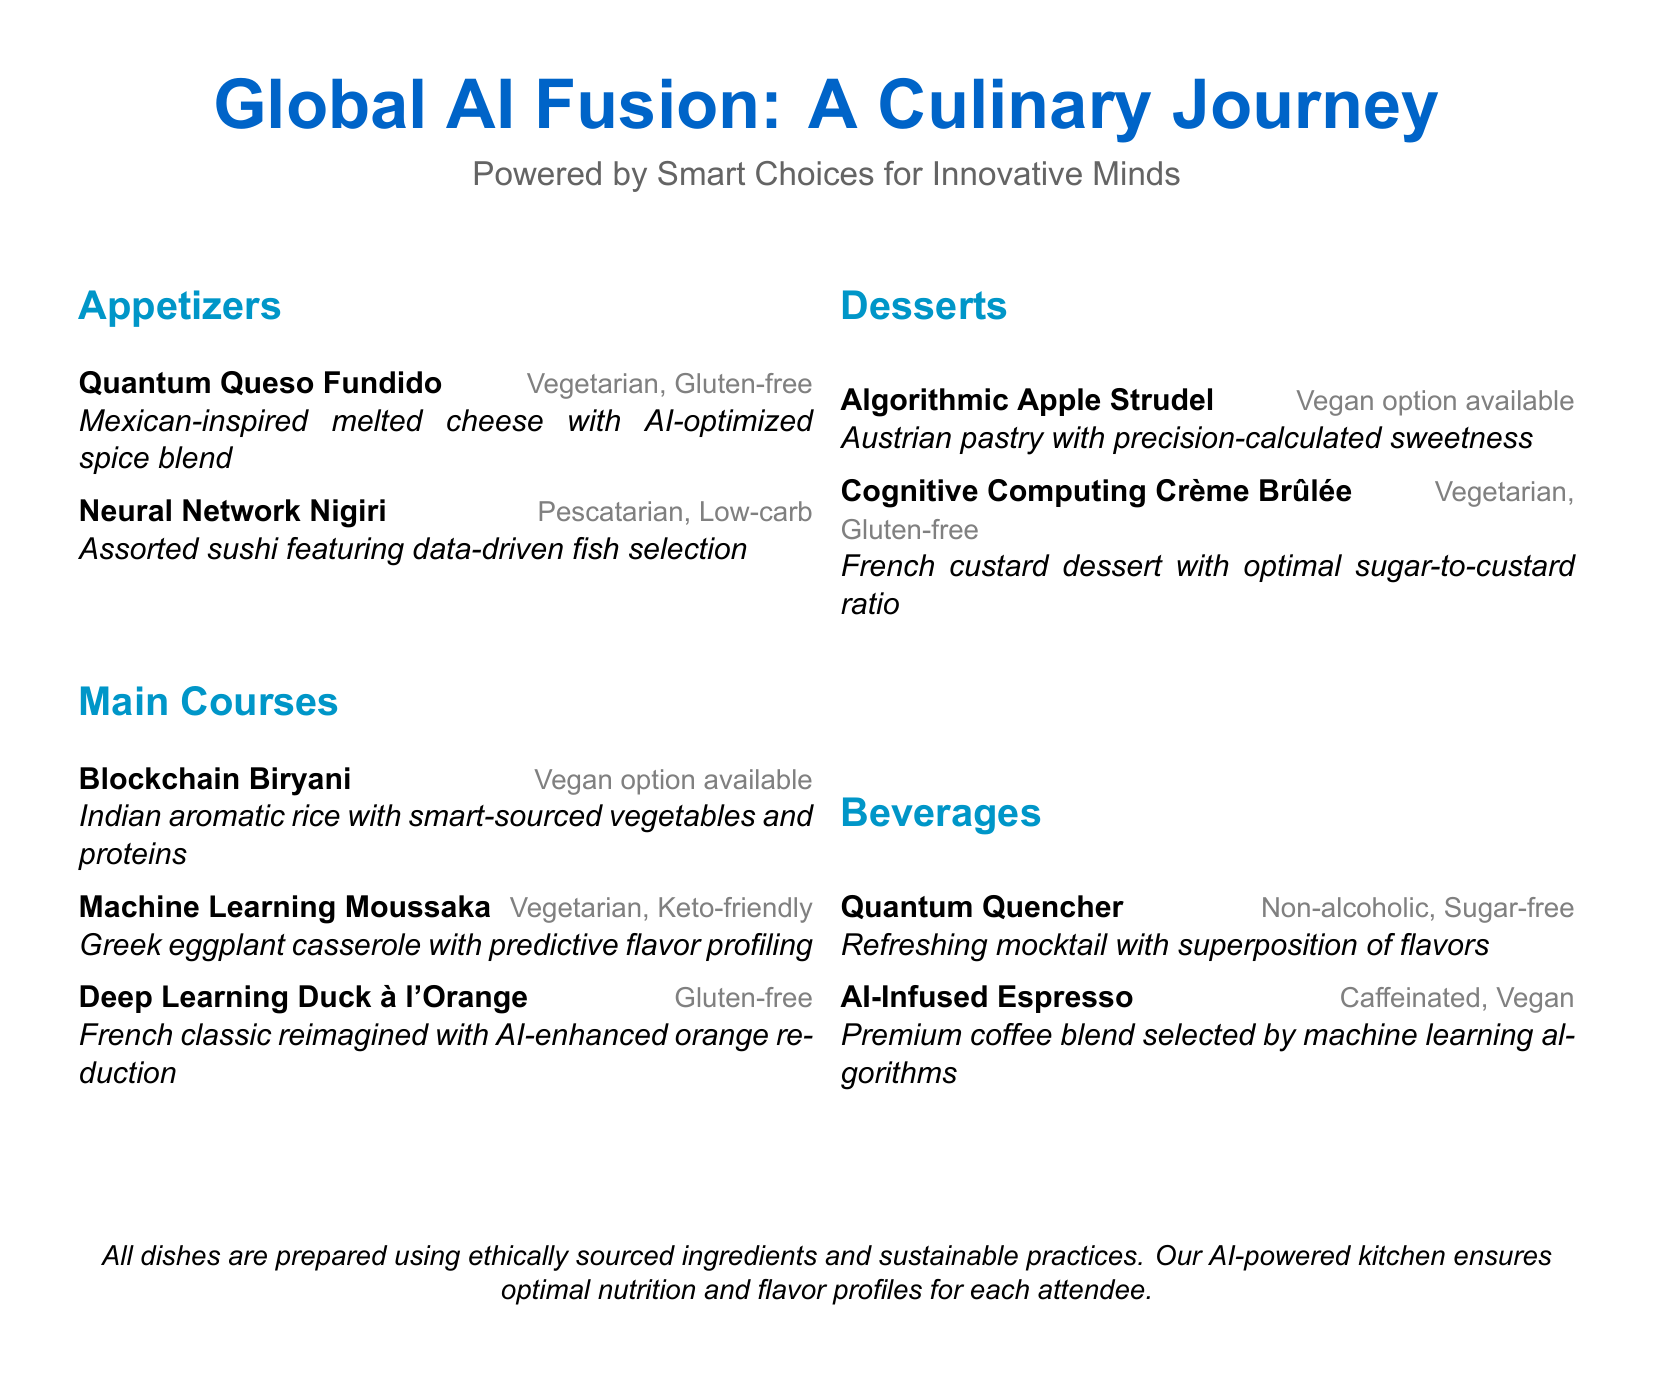What is the title of the menu? The title is prominently displayed at the top of the document, stating the theme of the culinary experience.
Answer: Global AI Fusion: A Culinary Journey How many sections are there in the menu? The menu is divided into four distinct sections, which can be counted in the document.
Answer: 4 What is the first appetizer listed? The first appetizer is the initial item mentioned in the Appetizers section of the menu.
Answer: Quantum Queso Fundido Which main course has a vegan option available? The main courses listed indicate which ones have dietary options specified.
Answer: Blockchain Biryani What kind of beverage is described as non-alcoholic? The beverages section includes a specific item that qualifies as non-alcoholic.
Answer: Quantum Quencher Which dessert has a gluten-free option? The desserts listed include specifics about dietary inclusions, including gluten-free options.
Answer: Cognitive Computing Crème Brûlée What cuisine is the Deep Learning Duck à l'Orange inspired by? The document states the traditional cuisine that the specific dish is a part of.
Answer: French What is the main ingredient in the Algorithmic Apple Strudel? The desserts section describes the primary component of each dessert, focusing on the first item.
Answer: Austrian pastry How are the ingredients described in the menu? The last section of the document summarizes the sourcing and preparation methods for the dishes.
Answer: Ethically sourced ingredients and sustainable practices 